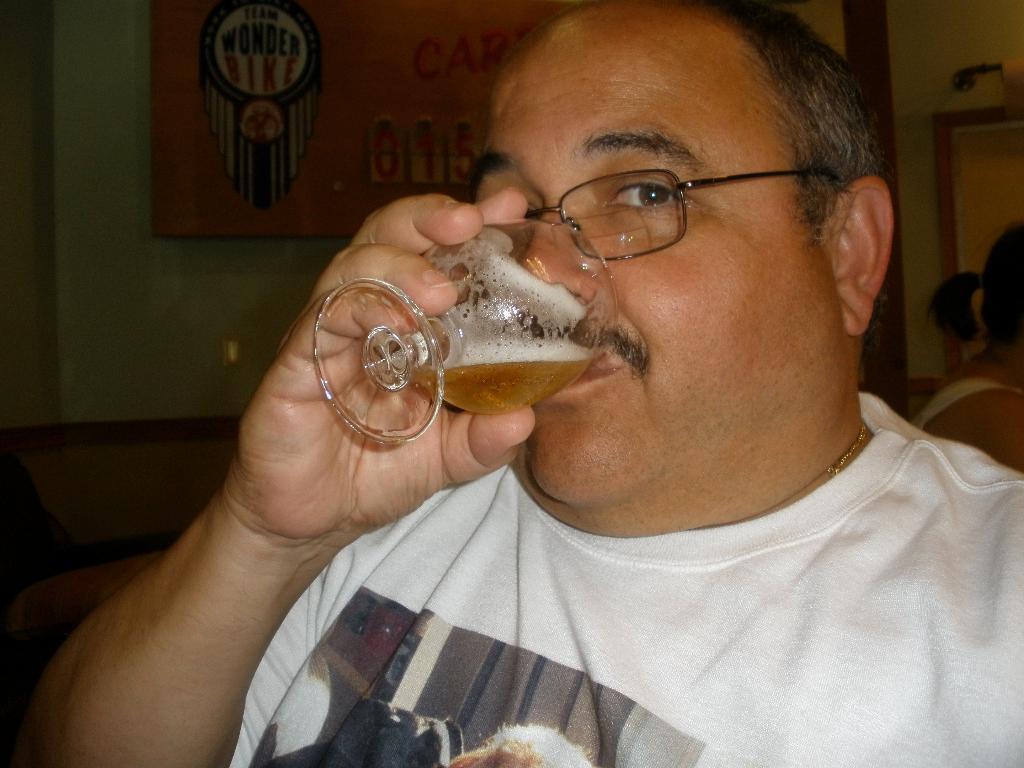Can you describe this image briefly? In this picture I can observe a man wearing white color T shirt. He is drinking some drink in the glass. The man is wearing spectacles. In the background I can observe a wall. 